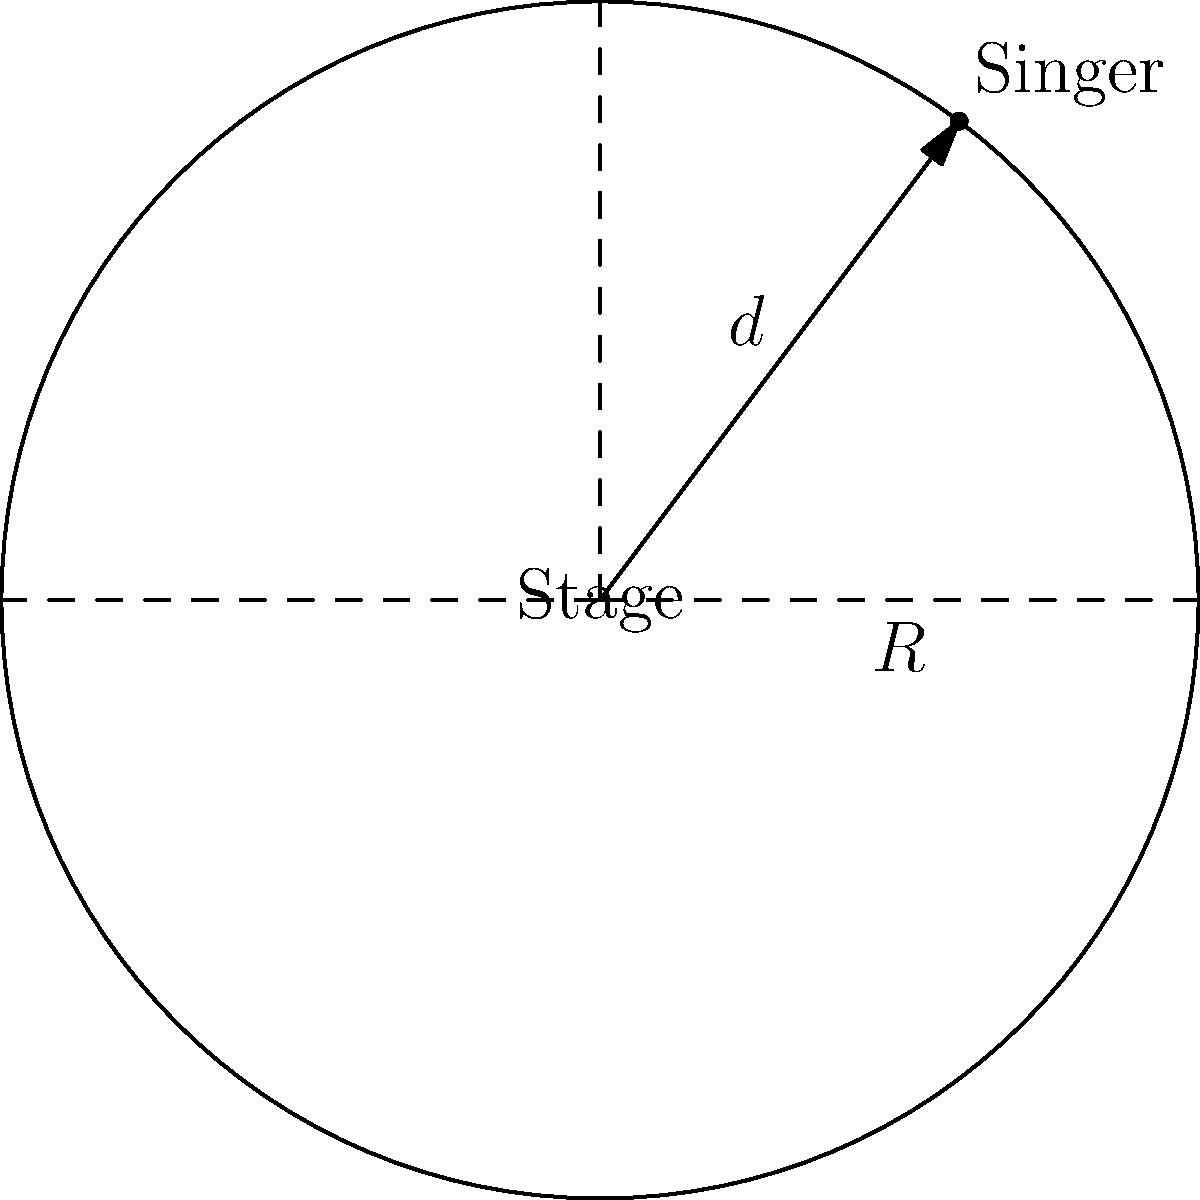As a singer-songwriter preparing for a performance at the Grand Ole Opry, you're considering the acoustics of a circular stage. The stage has a radius of 15 feet, and you plan to stand 12 feet from the center. If the sound projection is directly proportional to the remaining area of the stage in front of you, what percentage of the stage's total area contributes to your forward sound projection? Let's approach this step-by-step:

1) The total area of the circular stage is given by the formula:
   $$A_{total} = \pi R^2 = \pi (15^2) = 225\pi \text{ sq ft}$$

2) Your position on the stage forms a sector. The area of this sector represents the area behind you that doesn't contribute to forward sound projection.

3) To find the area of this sector, we first need to calculate the central angle $\theta$ (in radians):
   $$\cos(\theta/2) = 12/15 = 4/5$$
   $$\theta/2 = \arccos(4/5)$$
   $$\theta = 2\arccos(4/5)$$

4) The area of the sector is:
   $$A_{sector} = \frac{1}{2}R^2\theta = \frac{1}{2}(15^2)(2\arccos(4/5))$$
   $$A_{sector} = 225\arccos(4/5) \text{ sq ft}$$

5) The area contributing to forward sound projection is:
   $$A_{forward} = A_{total} - A_{sector}$$
   $$A_{forward} = 225\pi - 225\arccos(4/5) \text{ sq ft}$$

6) The percentage of the stage's area contributing to forward sound projection is:
   $$\text{Percentage} = \frac{A_{forward}}{A_{total}} \times 100\%$$
   $$= \frac{225\pi - 225\arccos(4/5)}{225\pi} \times 100\%$$
   $$= (1 - \frac{\arccos(4/5)}{\pi}) \times 100\%$$

7) Calculating this:
   $$\approx 67.79\%$$

Thus, approximately 67.79% of the stage's total area contributes to your forward sound projection.
Answer: 67.79% 